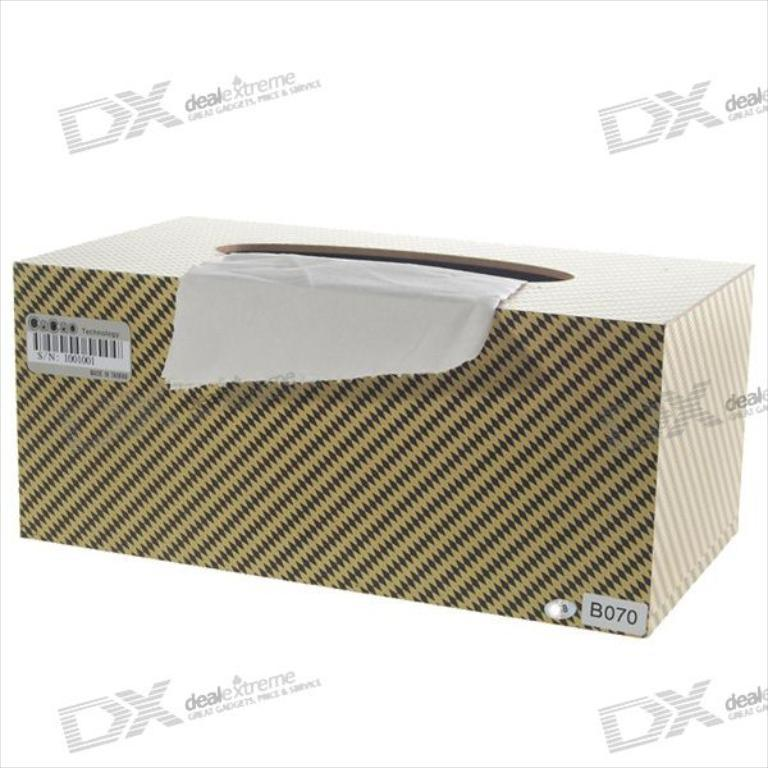<image>
Write a terse but informative summary of the picture. A tissue box is marked with the identifying code B070. 